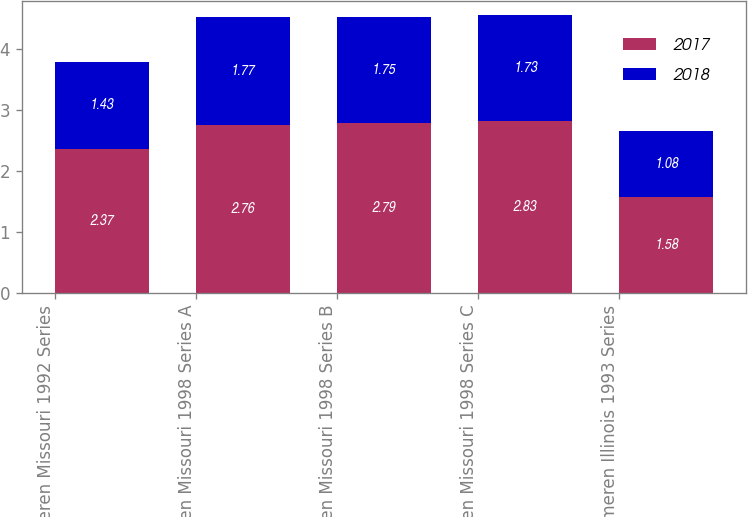Convert chart. <chart><loc_0><loc_0><loc_500><loc_500><stacked_bar_chart><ecel><fcel>Ameren Missouri 1992 Series<fcel>Ameren Missouri 1998 Series A<fcel>Ameren Missouri 1998 Series B<fcel>Ameren Missouri 1998 Series C<fcel>Ameren Illinois 1993 Series<nl><fcel>2017<fcel>2.37<fcel>2.76<fcel>2.79<fcel>2.83<fcel>1.58<nl><fcel>2018<fcel>1.43<fcel>1.77<fcel>1.75<fcel>1.73<fcel>1.08<nl></chart> 